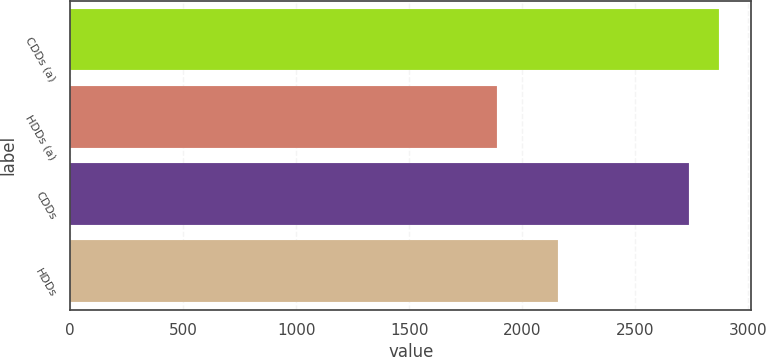<chart> <loc_0><loc_0><loc_500><loc_500><bar_chart><fcel>CDDs (a)<fcel>HDDs (a)<fcel>CDDs<fcel>HDDs<nl><fcel>2870<fcel>1887<fcel>2737<fcel>2157<nl></chart> 